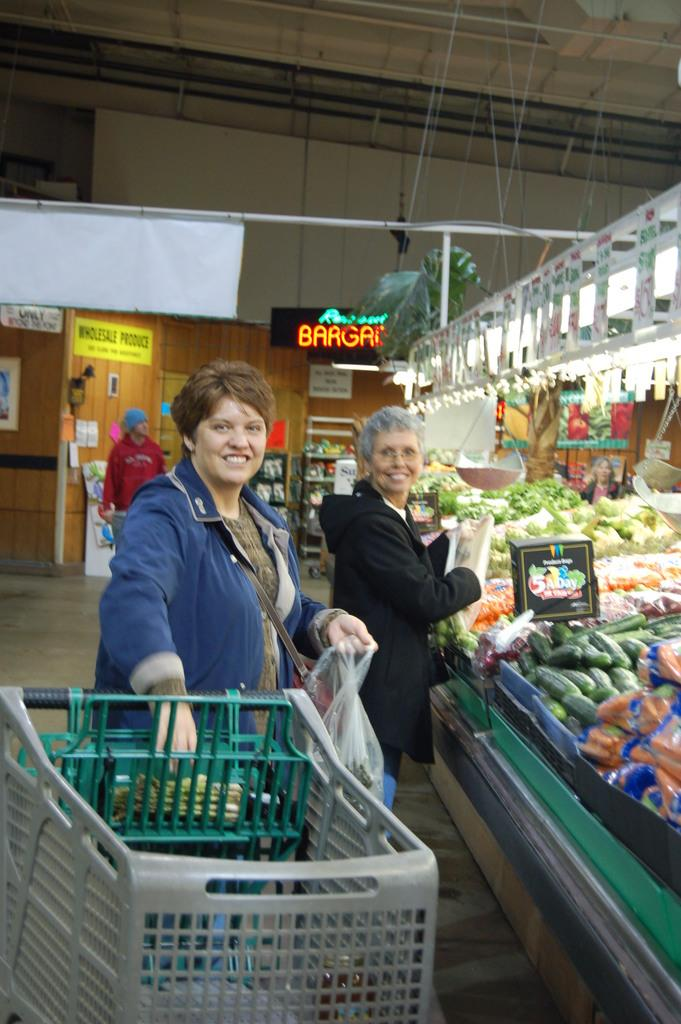<image>
Share a concise interpretation of the image provided. Two women are grocery shopping near the 5 a day sign in the produce section. 